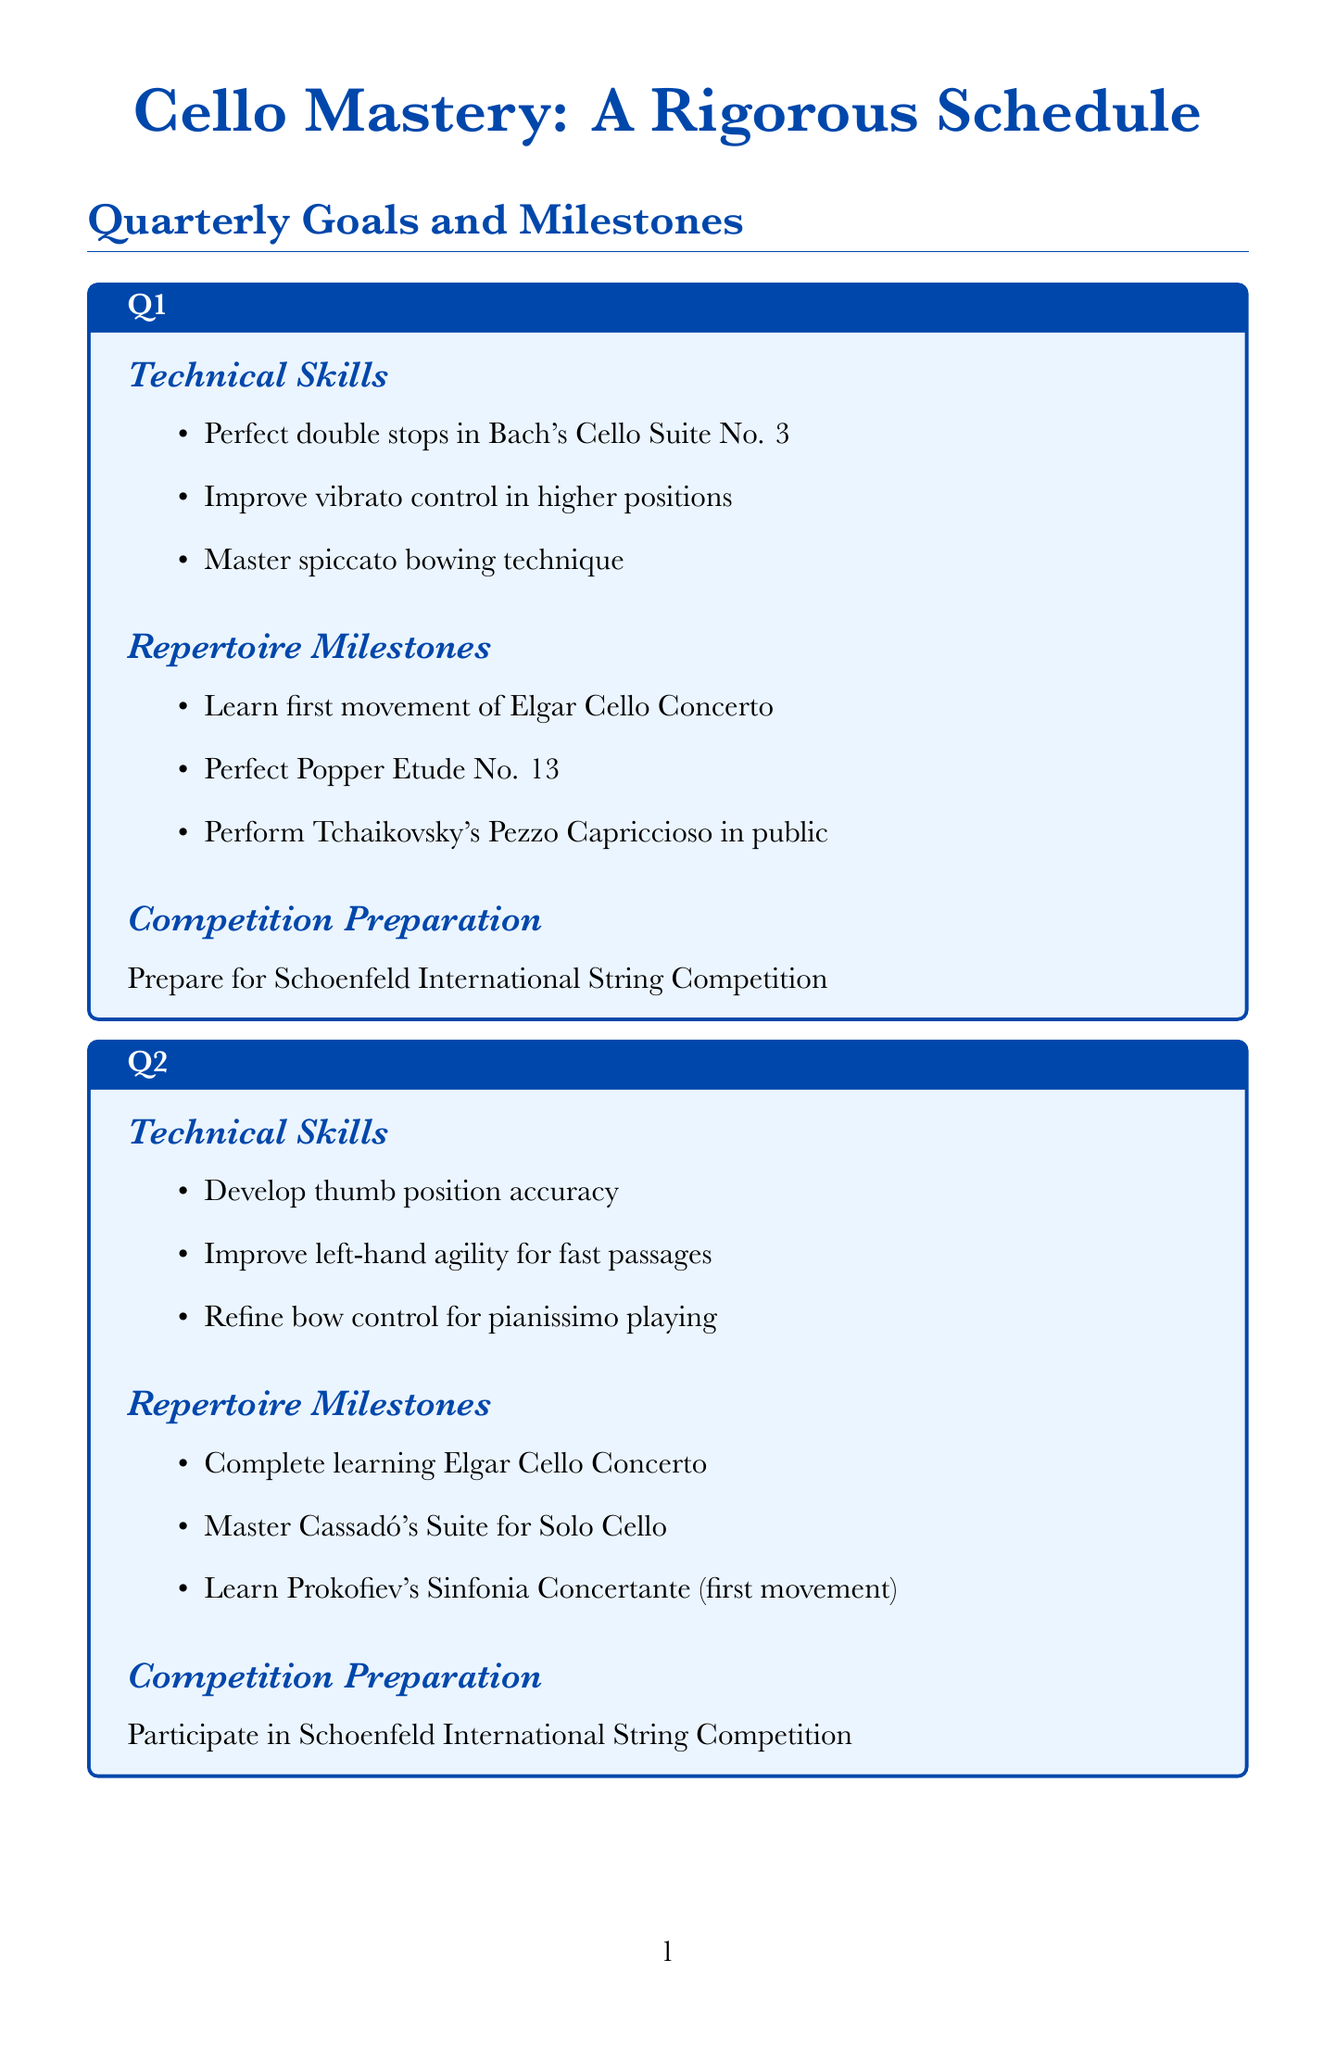What are the technical skills for Q1? The technical skills listed for Q1 include "Perfect double stops in Bach's Cello Suite No. 3," "Improve vibrato control in higher positions," and "Master spiccato bowing technique."
Answer: Perfect double stops in Bach's Cello Suite No. 3, Improve vibrato control in higher positions, Master spiccato bowing technique How many repertoire milestones are there in Q2? There are three specific repertoire milestones outlined for Q2: "Complete learning Elgar Cello Concerto," "Master Cassadó's Suite for Solo Cello," and "Learn Prokofiev's Sinfonia Concertante (first movement)."
Answer: 3 What event does the document prepare for in Q3? In Q3, the preparation is for participating in the "Paulo International Cello Competition," indicating a focus on competition readiness.
Answer: Paulo International Cello Competition Which cello concerto is performed publicly in Q1? The document states that "Tchaikovsky's Pezzo Capriccioso" is performed in public as a milestone in Q1.
Answer: Tchaikovsky's Pezzo Capriccioso What skill will be mastered in Q4? The Q4 goals include mastering "artificial harmonics," indicating a specific technical emphasis for that quarter.
Answer: artificial harmonics How many daily technical exercises are listed? The document lists three daily technical exercises, providing a structured practice approach for the cellist.
Answer: 3 Name one performance opportunity mentioned in the document. The document lists several performance opportunities, one of which is "Solo recital at Wigmore Hall."
Answer: Solo recital at Wigmore Hall What is the title of the document? The title given at the beginning of the document is "Cello Mastery: A Rigorous Schedule," reflecting its comprehensive approach.
Answer: Cello Mastery: A Rigorous Schedule 